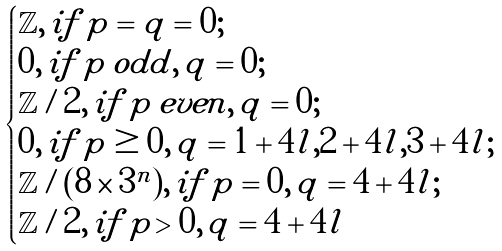Convert formula to latex. <formula><loc_0><loc_0><loc_500><loc_500>\begin{cases} \mathbb { Z } , \, i f \, p = q = 0 ; \\ 0 , \, i f \, p \, o d d , \, q = 0 ; \\ \mathbb { Z } / 2 , \, i f \, p \, e v e n , \, q = 0 ; \\ 0 , \, i f \, p \geq 0 , \, q = 1 + 4 l , 2 + 4 l , 3 + 4 l ; \\ \mathbb { Z } / ( 8 \times 3 ^ { n } ) , \, i f \, p = 0 , \, q = 4 + 4 l ; \\ \mathbb { Z } / 2 , \, i f \, p > 0 , \, q = 4 + 4 l \end{cases}</formula> 